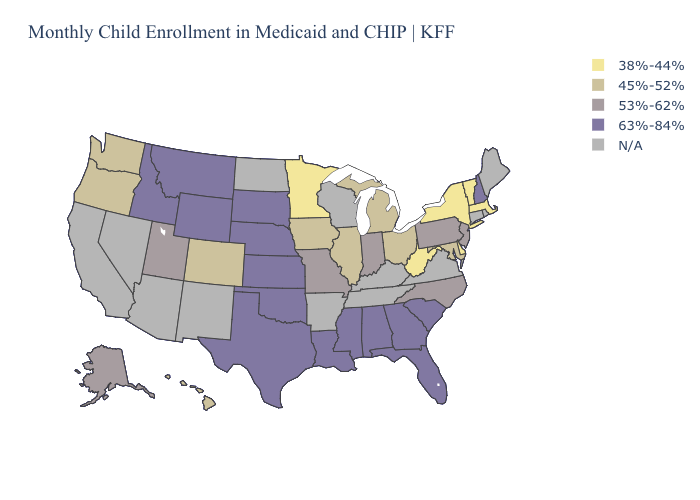What is the lowest value in the MidWest?
Short answer required. 38%-44%. What is the lowest value in the USA?
Keep it brief. 38%-44%. Name the states that have a value in the range 45%-52%?
Answer briefly. Colorado, Hawaii, Illinois, Iowa, Maryland, Michigan, Ohio, Oregon, Washington. Name the states that have a value in the range 45%-52%?
Write a very short answer. Colorado, Hawaii, Illinois, Iowa, Maryland, Michigan, Ohio, Oregon, Washington. Among the states that border Georgia , which have the lowest value?
Give a very brief answer. North Carolina. What is the highest value in states that border Indiana?
Concise answer only. 45%-52%. Name the states that have a value in the range 45%-52%?
Give a very brief answer. Colorado, Hawaii, Illinois, Iowa, Maryland, Michigan, Ohio, Oregon, Washington. Does Alabama have the lowest value in the South?
Give a very brief answer. No. Name the states that have a value in the range 38%-44%?
Short answer required. Delaware, Massachusetts, Minnesota, New York, Vermont, West Virginia. Which states have the highest value in the USA?
Concise answer only. Alabama, Florida, Georgia, Idaho, Kansas, Louisiana, Mississippi, Montana, Nebraska, New Hampshire, Oklahoma, South Carolina, South Dakota, Texas, Wyoming. What is the value of Iowa?
Write a very short answer. 45%-52%. Does the first symbol in the legend represent the smallest category?
Concise answer only. Yes. Name the states that have a value in the range 38%-44%?
Be succinct. Delaware, Massachusetts, Minnesota, New York, Vermont, West Virginia. Does Vermont have the lowest value in the Northeast?
Write a very short answer. Yes. Which states have the lowest value in the South?
Keep it brief. Delaware, West Virginia. 